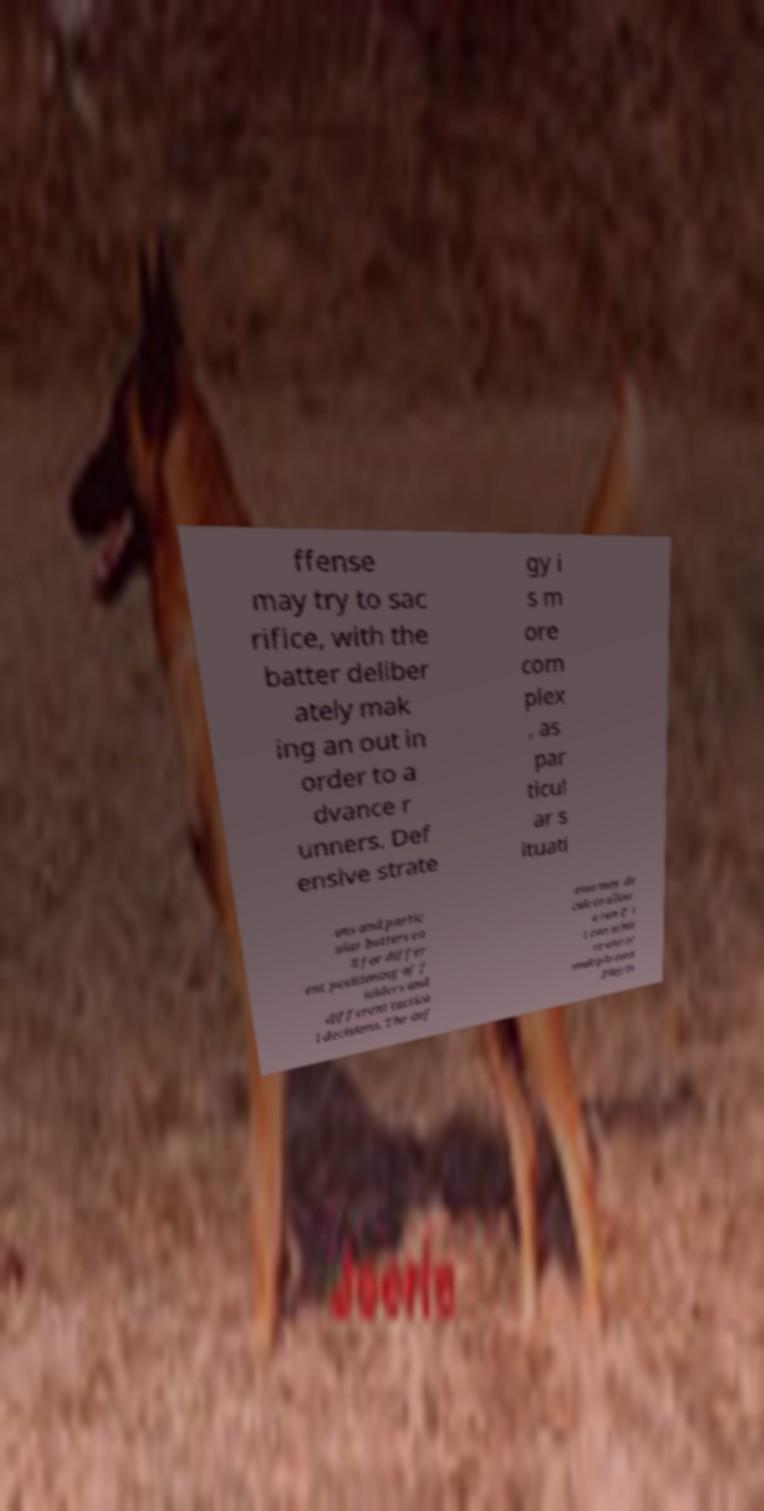Could you extract and type out the text from this image? ffense may try to sac rifice, with the batter deliber ately mak ing an out in order to a dvance r unners. Def ensive strate gy i s m ore com plex , as par ticul ar s ituati ons and partic ular batters ca ll for differ ent positioning of f ielders and different tactica l decisions. The def ense may de cide to allow a run if i t can achie ve one or multiple outs .Playin 